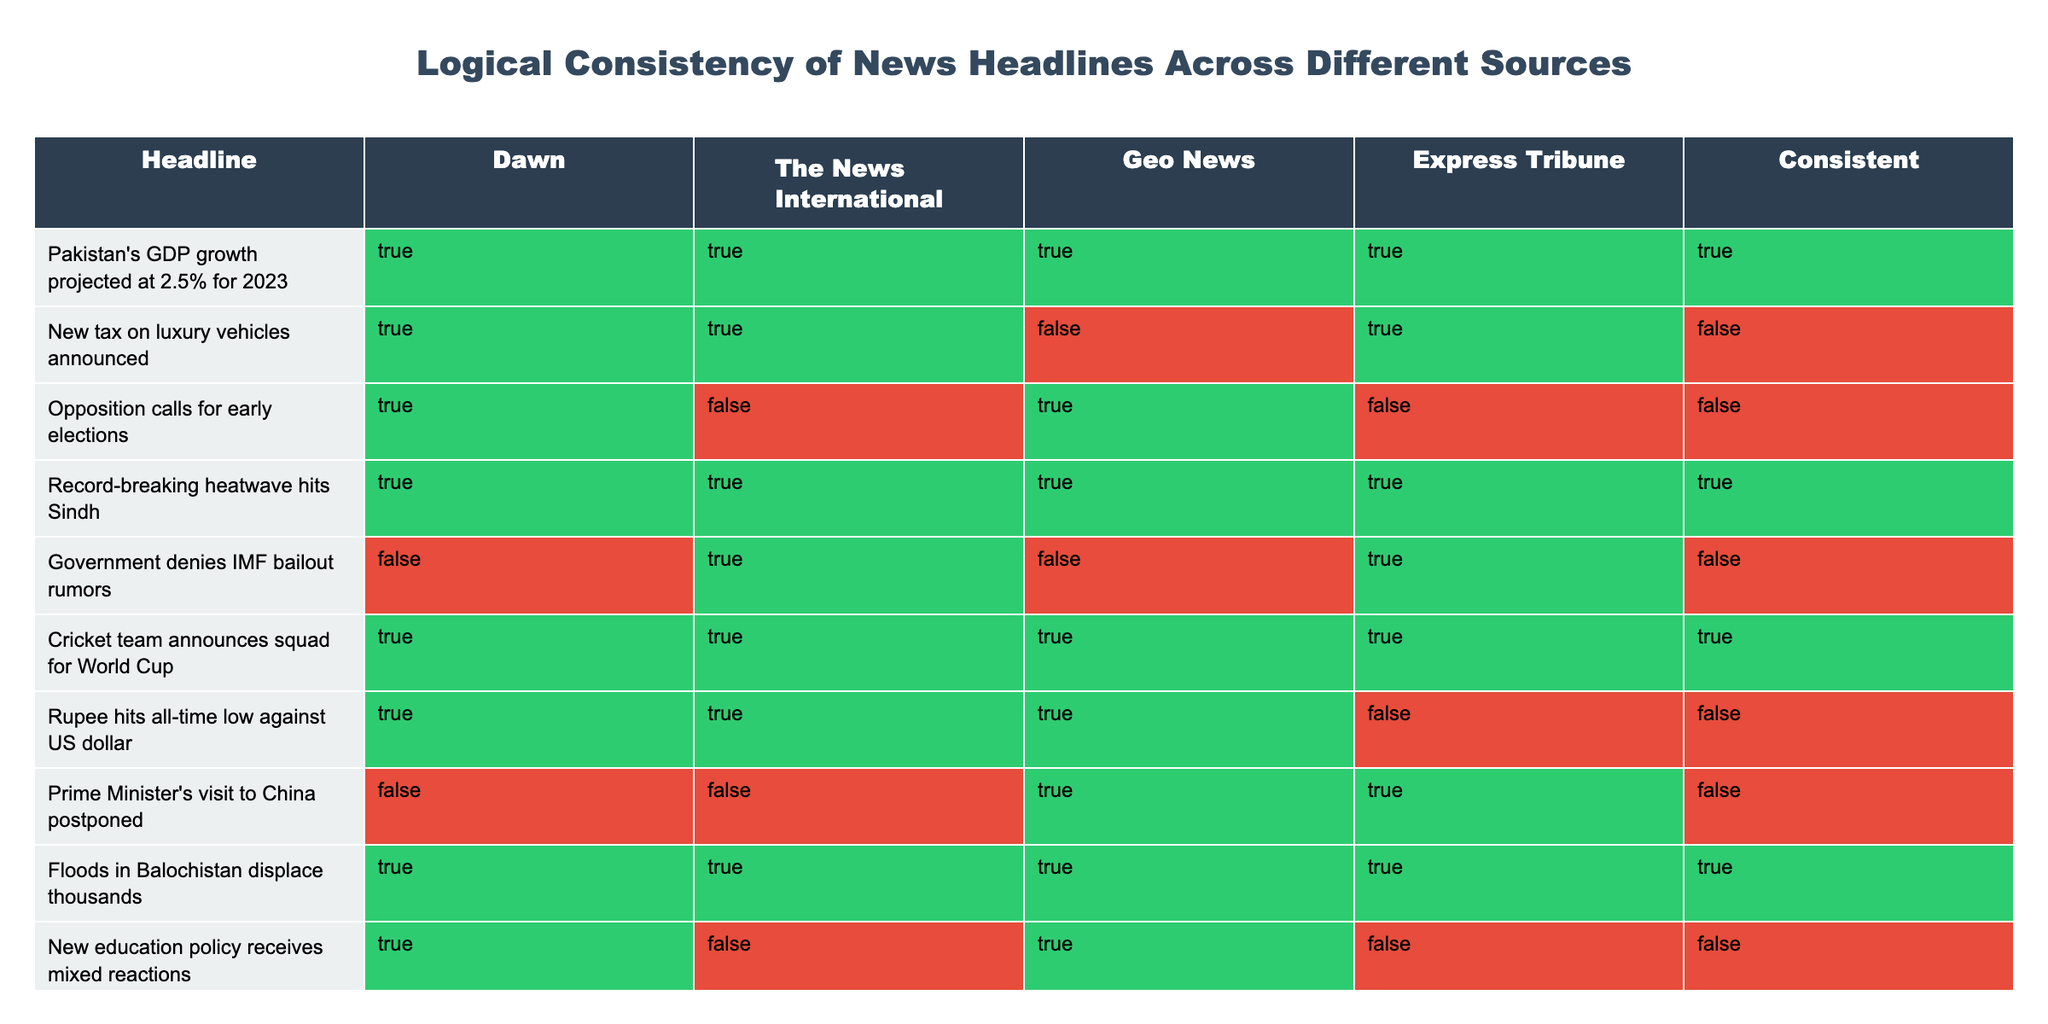What is the headline that is consistent across all four news sources? The only headline that shows 'TRUE' for all sources (Dawn, The News International, Geo News, and Express Tribune) is "Pakistan's GDP growth projected at 2.5% for 2023."
Answer: "Pakistan's GDP growth projected at 2.5% for 2023" How many headlines are inconsistent across at least one news source? The headlines that are inconsistent across at least one source are "New tax on luxury vehicles announced," "Opposition calls for early elections," "Government denies IMF bailout rumors," "Rupee hits all-time low against US dollar," "Prime Minister's visit to China postponed," and "New education policy receives mixed reactions." In total, this makes 6 inconsistent headlines.
Answer: 6 Is the headline "Record-breaking heatwave hits Sindh" consistent across all sources? Yes, the headline "Record-breaking heatwave hits Sindh" shows 'TRUE' for Dawn, The News International, Geo News, and Express Tribune, indicating consistency across all sources.
Answer: Yes Which headline has the highest number of sources confirming it? The headline "Floods in Balochistan displace thousands" has all four sources confirming, making it the headline with the highest consistency.
Answer: "Floods in Balochistan displace thousands" How many headlines are reported as inconsistent by Geo News? Geo News reports inconsistently on three headlines: "New tax on luxury vehicles announced," "Government denies IMF bailout rumors," and "New education policy receives mixed reactions." Therefore, the number of inconsistent headlines is 3.
Answer: 3 What is the total number of headlines listed in the table? There are 10 headlines provided in the table, as indicated by the number of rows of data describing news headlines.
Answer: 10 If we categorize the headlines into consistent and inconsistent, how many are consistent? There are 4 headlines marked as consistent, which are "Pakistan's GDP growth projected at 2.5% for 2023," "Record-breaking heatwave hits Sindh," "Cricket team announces squad for World Cup," and "Floods in Balochistan displace thousands."
Answer: 4 Which sources consistently agree on the headline "Rupee hits all-time low against US dollar"? Looking at the headline "Rupee hits all-time low against US dollar," both Dawn and The News International agree on it as consistent, while Geo News does not, and Express Tribune also shows inconsistency. Therefore, only two sources consistently agree.
Answer: 2 